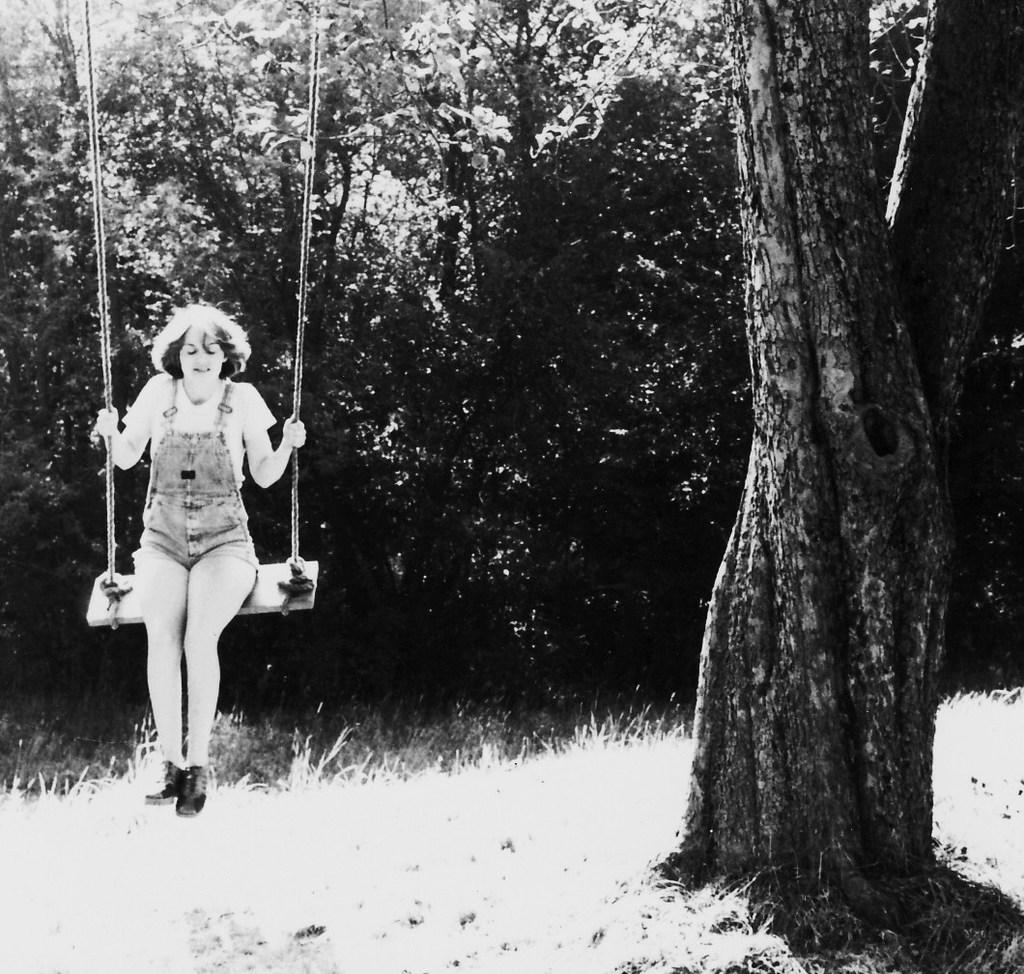Who is the main subject in the image? There is a woman in the image. What is the woman doing in the image? The woman is seated on a swing. What can be seen in the background of the image? There are trees in the background of the image. What is the color scheme of the image? The image is in black and white. How does the woman express her disgust in the image? There is no indication of disgust in the image; the woman is simply seated on a swing. Can you tell me how many times the woman kicks the ball in the image? There is no ball present in the image, so it is not possible to determine if the woman kicks it or how many times. 